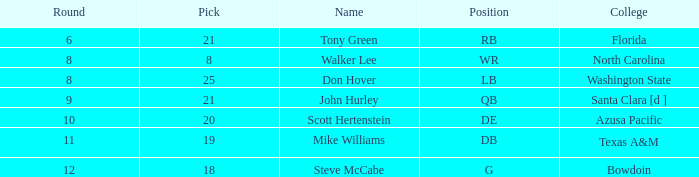In which college is the pick under 25, the overall above 159, the round lower than 10, and the position wide receiver? North Carolina. 